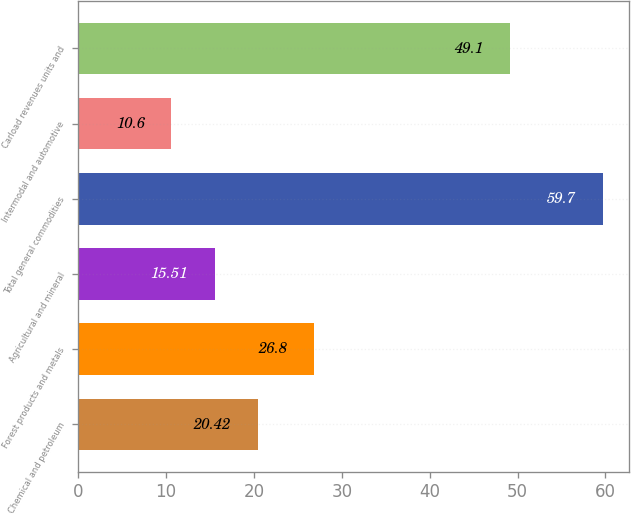<chart> <loc_0><loc_0><loc_500><loc_500><bar_chart><fcel>Chemical and petroleum<fcel>Forest products and metals<fcel>Agricultural and mineral<fcel>Total general commodities<fcel>Intermodal and automotive<fcel>Carload revenues units and<nl><fcel>20.42<fcel>26.8<fcel>15.51<fcel>59.7<fcel>10.6<fcel>49.1<nl></chart> 